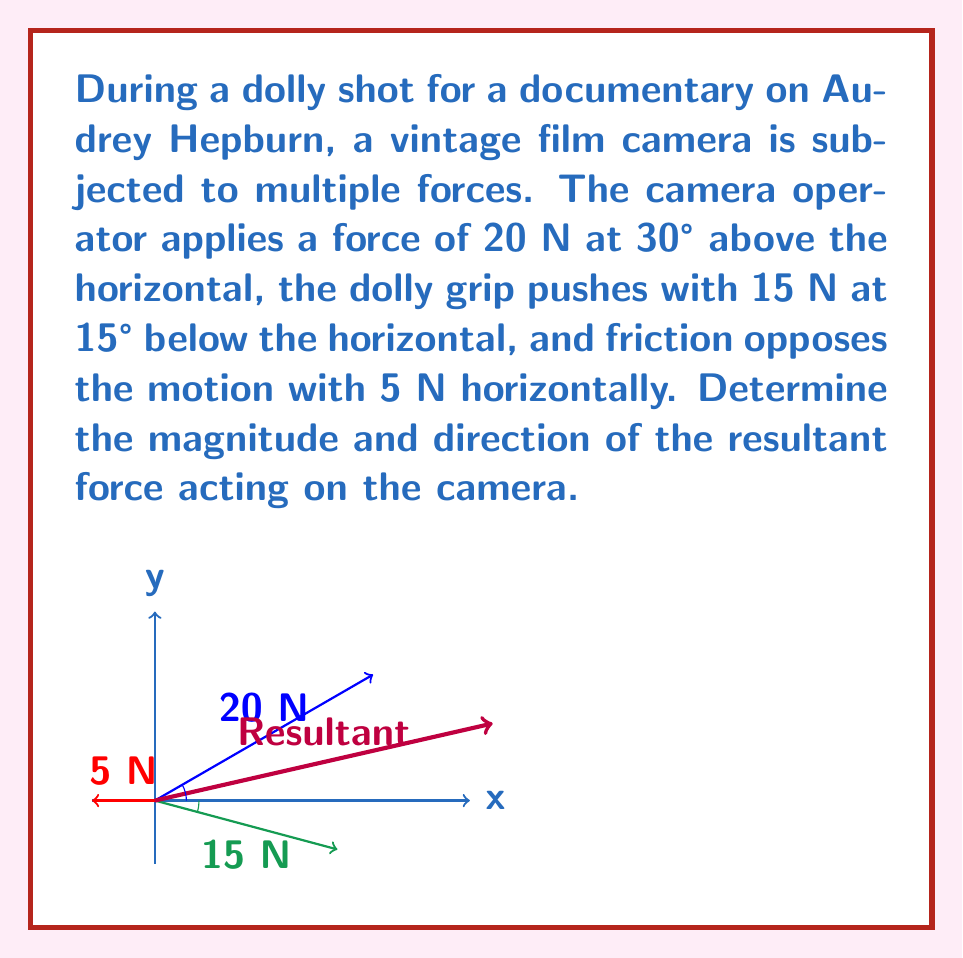Teach me how to tackle this problem. To solve this problem, we'll use vector addition. Let's break it down step-by-step:

1) First, let's decompose each force into its x and y components:

   Camera operator force (20 N at 30°):
   $F_{1x} = 20 \cos 30° = 17.32$ N
   $F_{1y} = 20 \sin 30° = 10$ N

   Dolly grip force (15 N at -15°):
   $F_{2x} = 15 \cos (-15°) = 14.48$ N
   $F_{2y} = 15 \sin (-15°) = -3.88$ N

   Friction force (5 N at 180°):
   $F_{3x} = -5$ N
   $F_{3y} = 0$ N

2) Now, sum up all x-components and y-components:

   $F_x = F_{1x} + F_{2x} + F_{3x} = 17.32 + 14.48 - 5 = 26.8$ N
   $F_y = F_{1y} + F_{2y} + F_{3y} = 10 - 3.88 + 0 = 6.12$ N

3) The resultant force vector is $(26.8, 6.12)$ N.

4) To find the magnitude of the resultant force, use the Pythagorean theorem:

   $F_R = \sqrt{F_x^2 + F_y^2} = \sqrt{26.8^2 + 6.12^2} = 27.49$ N

5) To find the direction, calculate the angle using arctangent:

   $\theta = \tan^{-1}(\frac{F_y}{F_x}) = \tan^{-1}(\frac{6.12}{26.8}) = 12.86°$

Therefore, the resultant force has a magnitude of 27.49 N and acts at an angle of 12.86° above the horizontal.
Answer: $27.49$ N at $12.86°$ above horizontal 